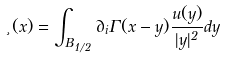Convert formula to latex. <formula><loc_0><loc_0><loc_500><loc_500>\xi ( x ) = \int _ { B _ { 1 / 2 } } \partial _ { i } \Gamma ( x - y ) \frac { u ( y ) } { | y | ^ { 2 } } d y</formula> 